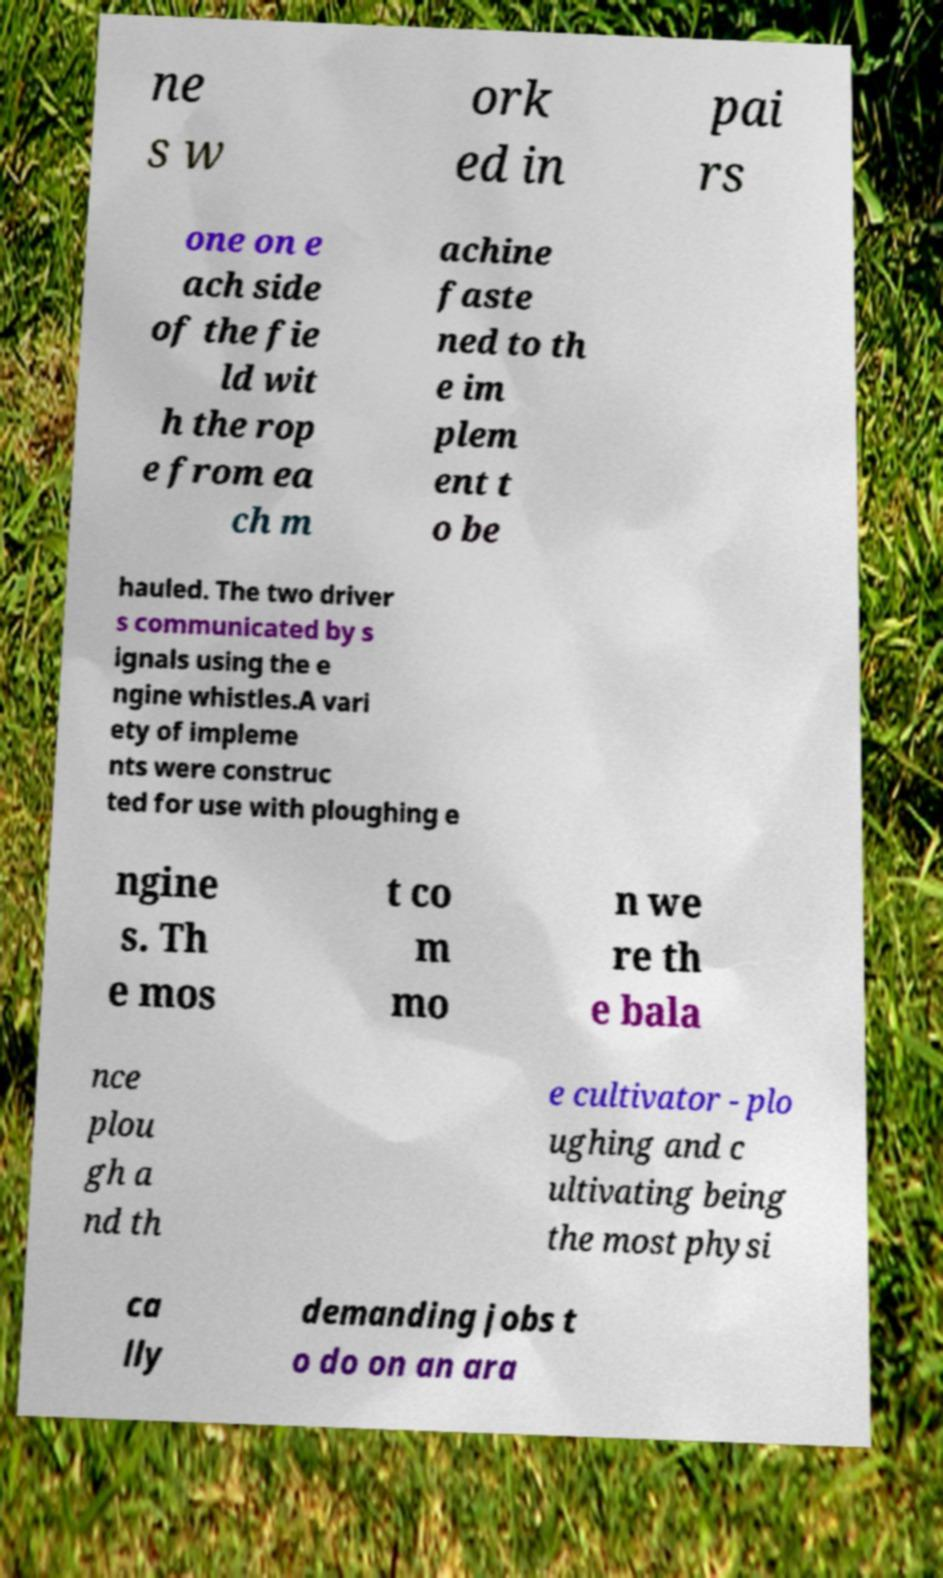Could you extract and type out the text from this image? ne s w ork ed in pai rs one on e ach side of the fie ld wit h the rop e from ea ch m achine faste ned to th e im plem ent t o be hauled. The two driver s communicated by s ignals using the e ngine whistles.A vari ety of impleme nts were construc ted for use with ploughing e ngine s. Th e mos t co m mo n we re th e bala nce plou gh a nd th e cultivator - plo ughing and c ultivating being the most physi ca lly demanding jobs t o do on an ara 